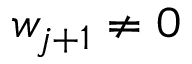<formula> <loc_0><loc_0><loc_500><loc_500>w _ { j + 1 } \neq 0</formula> 